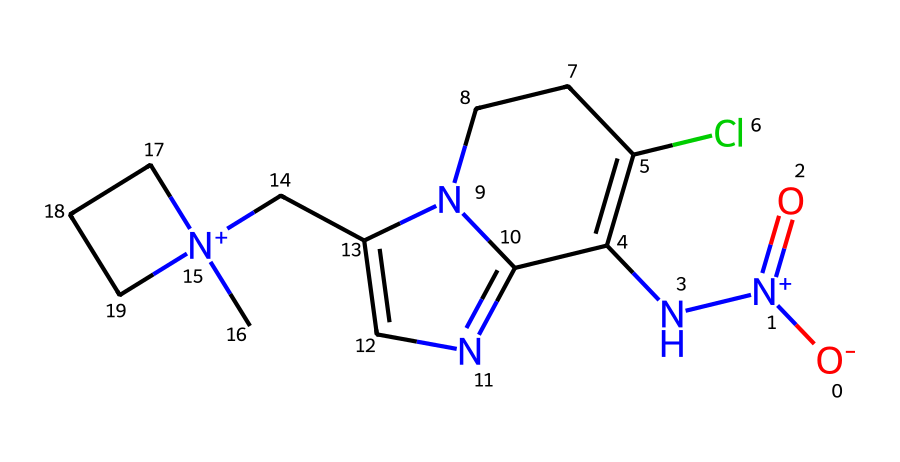What is the molecular weight of imidacloprid? To determine the molecular weight, we sum the atomic weights of each atom present in the chemical structure. The atoms in imidacloprid include carbon, hydrogen, chlorine, nitrogen, and oxygen. After calculating the contributions from each type of atom, we find that the total molecular weight is approximately 255.65 g/mol.
Answer: 255.65 g/mol How many nitrogen atoms are present in imidacloprid? By analyzing the SMILES structure, we can identify the positions of nitrogen atoms denoted by 'N'. There are a total of three nitrogen atoms in the structure of imidacloprid.
Answer: 3 What functional groups are present in imidacloprid? Looking closely at the structure, we identify specific functional groups such as an amine (due to the nitrogen atoms), a nitro group, and possibly a pyridine-like ring. These indicate the presence of specific chemical characteristics typical of imidacloprid.
Answer: amine, nitro, pyridine Which component of imidacloprid is responsible for its insecticidal activity? The structure of imidacloprid includes a niicotinic acetylcholine receptor agonist. The presence of the nitro group and the specific cyclic structures contribute to its ability to interact with these receptors, which is critical for its role as an insecticide.
Answer: nitro group Is imidacloprid considered a systemic pesticide? The chemical structure of imidacloprid suggests that it has properties allowing it to be absorbed and transport within plants, leading to its systemic effectiveness. This means it can be taken up by a plant and distributed throughout, effectively targeting pests that consume it.
Answer: yes 